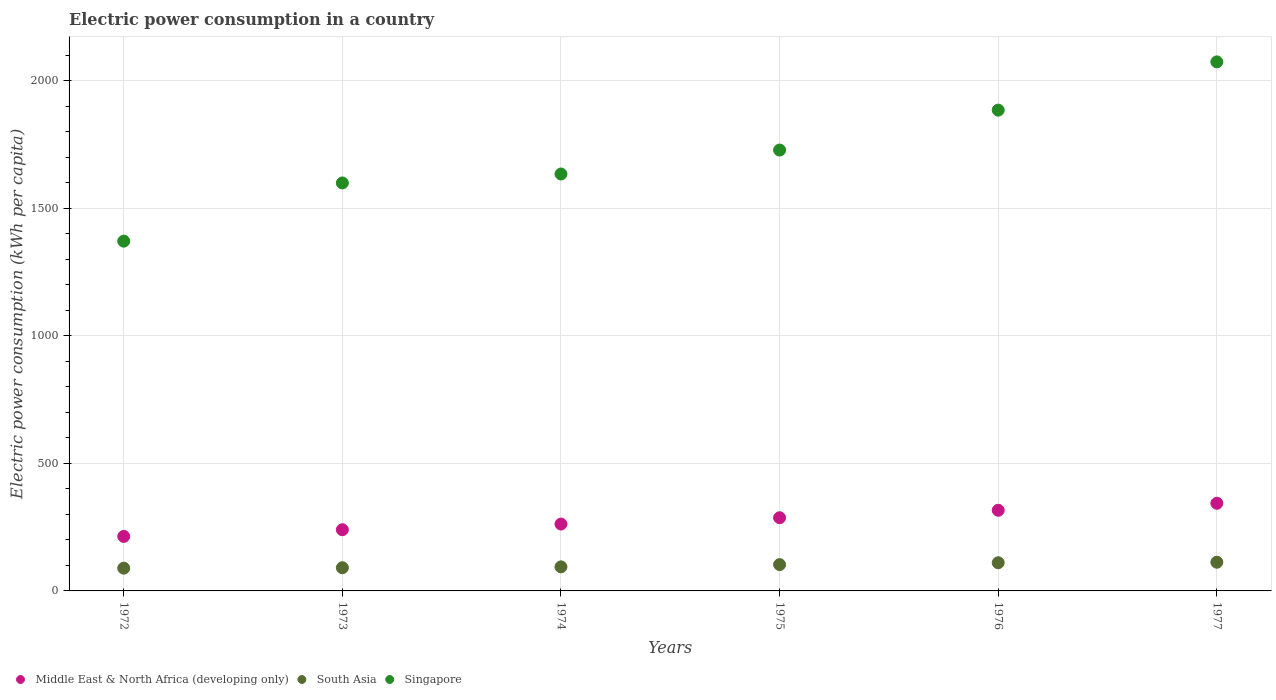Is the number of dotlines equal to the number of legend labels?
Make the answer very short. Yes. What is the electric power consumption in in South Asia in 1972?
Provide a succinct answer. 89.24. Across all years, what is the maximum electric power consumption in in South Asia?
Give a very brief answer. 112.5. Across all years, what is the minimum electric power consumption in in Middle East & North Africa (developing only)?
Your response must be concise. 213.69. In which year was the electric power consumption in in Singapore minimum?
Keep it short and to the point. 1972. What is the total electric power consumption in in Singapore in the graph?
Provide a short and direct response. 1.03e+04. What is the difference between the electric power consumption in in South Asia in 1973 and that in 1975?
Provide a short and direct response. -12.23. What is the difference between the electric power consumption in in Singapore in 1973 and the electric power consumption in in South Asia in 1976?
Ensure brevity in your answer.  1488.69. What is the average electric power consumption in in South Asia per year?
Provide a succinct answer. 100.08. In the year 1972, what is the difference between the electric power consumption in in South Asia and electric power consumption in in Singapore?
Keep it short and to the point. -1281.79. In how many years, is the electric power consumption in in Singapore greater than 1000 kWh per capita?
Offer a terse response. 6. What is the ratio of the electric power consumption in in Singapore in 1973 to that in 1976?
Offer a terse response. 0.85. Is the difference between the electric power consumption in in South Asia in 1973 and 1977 greater than the difference between the electric power consumption in in Singapore in 1973 and 1977?
Offer a terse response. Yes. What is the difference between the highest and the second highest electric power consumption in in South Asia?
Your answer should be compact. 2. What is the difference between the highest and the lowest electric power consumption in in Middle East & North Africa (developing only)?
Ensure brevity in your answer.  129.94. Is the electric power consumption in in South Asia strictly greater than the electric power consumption in in Middle East & North Africa (developing only) over the years?
Keep it short and to the point. No. How many years are there in the graph?
Provide a succinct answer. 6. Does the graph contain grids?
Your response must be concise. Yes. How are the legend labels stacked?
Ensure brevity in your answer.  Horizontal. What is the title of the graph?
Provide a succinct answer. Electric power consumption in a country. What is the label or title of the X-axis?
Offer a very short reply. Years. What is the label or title of the Y-axis?
Ensure brevity in your answer.  Electric power consumption (kWh per capita). What is the Electric power consumption (kWh per capita) in Middle East & North Africa (developing only) in 1972?
Provide a succinct answer. 213.69. What is the Electric power consumption (kWh per capita) of South Asia in 1972?
Give a very brief answer. 89.24. What is the Electric power consumption (kWh per capita) of Singapore in 1972?
Offer a very short reply. 1371.03. What is the Electric power consumption (kWh per capita) in Middle East & North Africa (developing only) in 1973?
Offer a terse response. 239.89. What is the Electric power consumption (kWh per capita) of South Asia in 1973?
Provide a short and direct response. 90.86. What is the Electric power consumption (kWh per capita) of Singapore in 1973?
Provide a short and direct response. 1599.18. What is the Electric power consumption (kWh per capita) in Middle East & North Africa (developing only) in 1974?
Your answer should be very brief. 262.09. What is the Electric power consumption (kWh per capita) of South Asia in 1974?
Your response must be concise. 94.28. What is the Electric power consumption (kWh per capita) in Singapore in 1974?
Offer a very short reply. 1634.23. What is the Electric power consumption (kWh per capita) of Middle East & North Africa (developing only) in 1975?
Offer a very short reply. 286.89. What is the Electric power consumption (kWh per capita) in South Asia in 1975?
Offer a terse response. 103.09. What is the Electric power consumption (kWh per capita) of Singapore in 1975?
Offer a very short reply. 1728.1. What is the Electric power consumption (kWh per capita) of Middle East & North Africa (developing only) in 1976?
Keep it short and to the point. 316.11. What is the Electric power consumption (kWh per capita) in South Asia in 1976?
Ensure brevity in your answer.  110.49. What is the Electric power consumption (kWh per capita) in Singapore in 1976?
Provide a short and direct response. 1884.62. What is the Electric power consumption (kWh per capita) of Middle East & North Africa (developing only) in 1977?
Keep it short and to the point. 343.64. What is the Electric power consumption (kWh per capita) in South Asia in 1977?
Ensure brevity in your answer.  112.5. What is the Electric power consumption (kWh per capita) of Singapore in 1977?
Your answer should be very brief. 2073.71. Across all years, what is the maximum Electric power consumption (kWh per capita) in Middle East & North Africa (developing only)?
Your response must be concise. 343.64. Across all years, what is the maximum Electric power consumption (kWh per capita) in South Asia?
Give a very brief answer. 112.5. Across all years, what is the maximum Electric power consumption (kWh per capita) in Singapore?
Ensure brevity in your answer.  2073.71. Across all years, what is the minimum Electric power consumption (kWh per capita) of Middle East & North Africa (developing only)?
Provide a succinct answer. 213.69. Across all years, what is the minimum Electric power consumption (kWh per capita) in South Asia?
Ensure brevity in your answer.  89.24. Across all years, what is the minimum Electric power consumption (kWh per capita) in Singapore?
Keep it short and to the point. 1371.03. What is the total Electric power consumption (kWh per capita) in Middle East & North Africa (developing only) in the graph?
Provide a short and direct response. 1662.3. What is the total Electric power consumption (kWh per capita) of South Asia in the graph?
Your answer should be compact. 600.47. What is the total Electric power consumption (kWh per capita) in Singapore in the graph?
Keep it short and to the point. 1.03e+04. What is the difference between the Electric power consumption (kWh per capita) in Middle East & North Africa (developing only) in 1972 and that in 1973?
Provide a succinct answer. -26.2. What is the difference between the Electric power consumption (kWh per capita) of South Asia in 1972 and that in 1973?
Your response must be concise. -1.62. What is the difference between the Electric power consumption (kWh per capita) in Singapore in 1972 and that in 1973?
Offer a terse response. -228.15. What is the difference between the Electric power consumption (kWh per capita) in Middle East & North Africa (developing only) in 1972 and that in 1974?
Keep it short and to the point. -48.4. What is the difference between the Electric power consumption (kWh per capita) in South Asia in 1972 and that in 1974?
Give a very brief answer. -5.04. What is the difference between the Electric power consumption (kWh per capita) in Singapore in 1972 and that in 1974?
Keep it short and to the point. -263.2. What is the difference between the Electric power consumption (kWh per capita) of Middle East & North Africa (developing only) in 1972 and that in 1975?
Offer a very short reply. -73.19. What is the difference between the Electric power consumption (kWh per capita) in South Asia in 1972 and that in 1975?
Provide a short and direct response. -13.85. What is the difference between the Electric power consumption (kWh per capita) of Singapore in 1972 and that in 1975?
Give a very brief answer. -357.07. What is the difference between the Electric power consumption (kWh per capita) of Middle East & North Africa (developing only) in 1972 and that in 1976?
Offer a very short reply. -102.41. What is the difference between the Electric power consumption (kWh per capita) of South Asia in 1972 and that in 1976?
Ensure brevity in your answer.  -21.25. What is the difference between the Electric power consumption (kWh per capita) of Singapore in 1972 and that in 1976?
Your response must be concise. -513.59. What is the difference between the Electric power consumption (kWh per capita) of Middle East & North Africa (developing only) in 1972 and that in 1977?
Ensure brevity in your answer.  -129.94. What is the difference between the Electric power consumption (kWh per capita) of South Asia in 1972 and that in 1977?
Ensure brevity in your answer.  -23.25. What is the difference between the Electric power consumption (kWh per capita) of Singapore in 1972 and that in 1977?
Your response must be concise. -702.68. What is the difference between the Electric power consumption (kWh per capita) in Middle East & North Africa (developing only) in 1973 and that in 1974?
Give a very brief answer. -22.2. What is the difference between the Electric power consumption (kWh per capita) in South Asia in 1973 and that in 1974?
Provide a succinct answer. -3.42. What is the difference between the Electric power consumption (kWh per capita) of Singapore in 1973 and that in 1974?
Provide a short and direct response. -35.05. What is the difference between the Electric power consumption (kWh per capita) of Middle East & North Africa (developing only) in 1973 and that in 1975?
Your response must be concise. -47. What is the difference between the Electric power consumption (kWh per capita) in South Asia in 1973 and that in 1975?
Your answer should be compact. -12.23. What is the difference between the Electric power consumption (kWh per capita) in Singapore in 1973 and that in 1975?
Your answer should be compact. -128.92. What is the difference between the Electric power consumption (kWh per capita) of Middle East & North Africa (developing only) in 1973 and that in 1976?
Make the answer very short. -76.22. What is the difference between the Electric power consumption (kWh per capita) of South Asia in 1973 and that in 1976?
Ensure brevity in your answer.  -19.63. What is the difference between the Electric power consumption (kWh per capita) of Singapore in 1973 and that in 1976?
Provide a short and direct response. -285.44. What is the difference between the Electric power consumption (kWh per capita) in Middle East & North Africa (developing only) in 1973 and that in 1977?
Your answer should be very brief. -103.75. What is the difference between the Electric power consumption (kWh per capita) of South Asia in 1973 and that in 1977?
Your answer should be compact. -21.63. What is the difference between the Electric power consumption (kWh per capita) of Singapore in 1973 and that in 1977?
Keep it short and to the point. -474.53. What is the difference between the Electric power consumption (kWh per capita) in Middle East & North Africa (developing only) in 1974 and that in 1975?
Your answer should be compact. -24.8. What is the difference between the Electric power consumption (kWh per capita) of South Asia in 1974 and that in 1975?
Ensure brevity in your answer.  -8.81. What is the difference between the Electric power consumption (kWh per capita) of Singapore in 1974 and that in 1975?
Provide a succinct answer. -93.87. What is the difference between the Electric power consumption (kWh per capita) in Middle East & North Africa (developing only) in 1974 and that in 1976?
Your answer should be very brief. -54.02. What is the difference between the Electric power consumption (kWh per capita) in South Asia in 1974 and that in 1976?
Offer a very short reply. -16.21. What is the difference between the Electric power consumption (kWh per capita) in Singapore in 1974 and that in 1976?
Your answer should be very brief. -250.39. What is the difference between the Electric power consumption (kWh per capita) of Middle East & North Africa (developing only) in 1974 and that in 1977?
Make the answer very short. -81.54. What is the difference between the Electric power consumption (kWh per capita) of South Asia in 1974 and that in 1977?
Your response must be concise. -18.21. What is the difference between the Electric power consumption (kWh per capita) in Singapore in 1974 and that in 1977?
Your answer should be compact. -439.48. What is the difference between the Electric power consumption (kWh per capita) of Middle East & North Africa (developing only) in 1975 and that in 1976?
Make the answer very short. -29.22. What is the difference between the Electric power consumption (kWh per capita) of South Asia in 1975 and that in 1976?
Provide a succinct answer. -7.4. What is the difference between the Electric power consumption (kWh per capita) in Singapore in 1975 and that in 1976?
Provide a short and direct response. -156.52. What is the difference between the Electric power consumption (kWh per capita) of Middle East & North Africa (developing only) in 1975 and that in 1977?
Provide a short and direct response. -56.75. What is the difference between the Electric power consumption (kWh per capita) in South Asia in 1975 and that in 1977?
Offer a very short reply. -9.4. What is the difference between the Electric power consumption (kWh per capita) of Singapore in 1975 and that in 1977?
Offer a very short reply. -345.61. What is the difference between the Electric power consumption (kWh per capita) in Middle East & North Africa (developing only) in 1976 and that in 1977?
Make the answer very short. -27.53. What is the difference between the Electric power consumption (kWh per capita) of South Asia in 1976 and that in 1977?
Give a very brief answer. -2. What is the difference between the Electric power consumption (kWh per capita) of Singapore in 1976 and that in 1977?
Your response must be concise. -189.09. What is the difference between the Electric power consumption (kWh per capita) in Middle East & North Africa (developing only) in 1972 and the Electric power consumption (kWh per capita) in South Asia in 1973?
Provide a succinct answer. 122.83. What is the difference between the Electric power consumption (kWh per capita) of Middle East & North Africa (developing only) in 1972 and the Electric power consumption (kWh per capita) of Singapore in 1973?
Make the answer very short. -1385.49. What is the difference between the Electric power consumption (kWh per capita) of South Asia in 1972 and the Electric power consumption (kWh per capita) of Singapore in 1973?
Make the answer very short. -1509.94. What is the difference between the Electric power consumption (kWh per capita) in Middle East & North Africa (developing only) in 1972 and the Electric power consumption (kWh per capita) in South Asia in 1974?
Provide a succinct answer. 119.41. What is the difference between the Electric power consumption (kWh per capita) of Middle East & North Africa (developing only) in 1972 and the Electric power consumption (kWh per capita) of Singapore in 1974?
Your answer should be compact. -1420.53. What is the difference between the Electric power consumption (kWh per capita) in South Asia in 1972 and the Electric power consumption (kWh per capita) in Singapore in 1974?
Give a very brief answer. -1544.98. What is the difference between the Electric power consumption (kWh per capita) in Middle East & North Africa (developing only) in 1972 and the Electric power consumption (kWh per capita) in South Asia in 1975?
Provide a succinct answer. 110.6. What is the difference between the Electric power consumption (kWh per capita) in Middle East & North Africa (developing only) in 1972 and the Electric power consumption (kWh per capita) in Singapore in 1975?
Ensure brevity in your answer.  -1514.41. What is the difference between the Electric power consumption (kWh per capita) in South Asia in 1972 and the Electric power consumption (kWh per capita) in Singapore in 1975?
Keep it short and to the point. -1638.86. What is the difference between the Electric power consumption (kWh per capita) in Middle East & North Africa (developing only) in 1972 and the Electric power consumption (kWh per capita) in South Asia in 1976?
Offer a terse response. 103.2. What is the difference between the Electric power consumption (kWh per capita) of Middle East & North Africa (developing only) in 1972 and the Electric power consumption (kWh per capita) of Singapore in 1976?
Your answer should be very brief. -1670.93. What is the difference between the Electric power consumption (kWh per capita) in South Asia in 1972 and the Electric power consumption (kWh per capita) in Singapore in 1976?
Your answer should be compact. -1795.38. What is the difference between the Electric power consumption (kWh per capita) of Middle East & North Africa (developing only) in 1972 and the Electric power consumption (kWh per capita) of South Asia in 1977?
Offer a terse response. 101.2. What is the difference between the Electric power consumption (kWh per capita) in Middle East & North Africa (developing only) in 1972 and the Electric power consumption (kWh per capita) in Singapore in 1977?
Provide a short and direct response. -1860.02. What is the difference between the Electric power consumption (kWh per capita) in South Asia in 1972 and the Electric power consumption (kWh per capita) in Singapore in 1977?
Provide a succinct answer. -1984.47. What is the difference between the Electric power consumption (kWh per capita) of Middle East & North Africa (developing only) in 1973 and the Electric power consumption (kWh per capita) of South Asia in 1974?
Offer a very short reply. 145.61. What is the difference between the Electric power consumption (kWh per capita) in Middle East & North Africa (developing only) in 1973 and the Electric power consumption (kWh per capita) in Singapore in 1974?
Give a very brief answer. -1394.34. What is the difference between the Electric power consumption (kWh per capita) in South Asia in 1973 and the Electric power consumption (kWh per capita) in Singapore in 1974?
Ensure brevity in your answer.  -1543.37. What is the difference between the Electric power consumption (kWh per capita) of Middle East & North Africa (developing only) in 1973 and the Electric power consumption (kWh per capita) of South Asia in 1975?
Make the answer very short. 136.8. What is the difference between the Electric power consumption (kWh per capita) of Middle East & North Africa (developing only) in 1973 and the Electric power consumption (kWh per capita) of Singapore in 1975?
Offer a terse response. -1488.21. What is the difference between the Electric power consumption (kWh per capita) in South Asia in 1973 and the Electric power consumption (kWh per capita) in Singapore in 1975?
Offer a terse response. -1637.24. What is the difference between the Electric power consumption (kWh per capita) in Middle East & North Africa (developing only) in 1973 and the Electric power consumption (kWh per capita) in South Asia in 1976?
Your answer should be compact. 129.4. What is the difference between the Electric power consumption (kWh per capita) of Middle East & North Africa (developing only) in 1973 and the Electric power consumption (kWh per capita) of Singapore in 1976?
Offer a very short reply. -1644.73. What is the difference between the Electric power consumption (kWh per capita) of South Asia in 1973 and the Electric power consumption (kWh per capita) of Singapore in 1976?
Make the answer very short. -1793.76. What is the difference between the Electric power consumption (kWh per capita) in Middle East & North Africa (developing only) in 1973 and the Electric power consumption (kWh per capita) in South Asia in 1977?
Ensure brevity in your answer.  127.39. What is the difference between the Electric power consumption (kWh per capita) of Middle East & North Africa (developing only) in 1973 and the Electric power consumption (kWh per capita) of Singapore in 1977?
Keep it short and to the point. -1833.82. What is the difference between the Electric power consumption (kWh per capita) of South Asia in 1973 and the Electric power consumption (kWh per capita) of Singapore in 1977?
Provide a short and direct response. -1982.85. What is the difference between the Electric power consumption (kWh per capita) of Middle East & North Africa (developing only) in 1974 and the Electric power consumption (kWh per capita) of South Asia in 1975?
Make the answer very short. 159. What is the difference between the Electric power consumption (kWh per capita) in Middle East & North Africa (developing only) in 1974 and the Electric power consumption (kWh per capita) in Singapore in 1975?
Provide a short and direct response. -1466.01. What is the difference between the Electric power consumption (kWh per capita) in South Asia in 1974 and the Electric power consumption (kWh per capita) in Singapore in 1975?
Offer a very short reply. -1633.82. What is the difference between the Electric power consumption (kWh per capita) in Middle East & North Africa (developing only) in 1974 and the Electric power consumption (kWh per capita) in South Asia in 1976?
Your answer should be very brief. 151.6. What is the difference between the Electric power consumption (kWh per capita) in Middle East & North Africa (developing only) in 1974 and the Electric power consumption (kWh per capita) in Singapore in 1976?
Keep it short and to the point. -1622.53. What is the difference between the Electric power consumption (kWh per capita) in South Asia in 1974 and the Electric power consumption (kWh per capita) in Singapore in 1976?
Offer a very short reply. -1790.34. What is the difference between the Electric power consumption (kWh per capita) in Middle East & North Africa (developing only) in 1974 and the Electric power consumption (kWh per capita) in South Asia in 1977?
Offer a terse response. 149.6. What is the difference between the Electric power consumption (kWh per capita) of Middle East & North Africa (developing only) in 1974 and the Electric power consumption (kWh per capita) of Singapore in 1977?
Keep it short and to the point. -1811.62. What is the difference between the Electric power consumption (kWh per capita) in South Asia in 1974 and the Electric power consumption (kWh per capita) in Singapore in 1977?
Keep it short and to the point. -1979.43. What is the difference between the Electric power consumption (kWh per capita) in Middle East & North Africa (developing only) in 1975 and the Electric power consumption (kWh per capita) in South Asia in 1976?
Give a very brief answer. 176.4. What is the difference between the Electric power consumption (kWh per capita) of Middle East & North Africa (developing only) in 1975 and the Electric power consumption (kWh per capita) of Singapore in 1976?
Ensure brevity in your answer.  -1597.73. What is the difference between the Electric power consumption (kWh per capita) of South Asia in 1975 and the Electric power consumption (kWh per capita) of Singapore in 1976?
Your answer should be compact. -1781.53. What is the difference between the Electric power consumption (kWh per capita) in Middle East & North Africa (developing only) in 1975 and the Electric power consumption (kWh per capita) in South Asia in 1977?
Offer a very short reply. 174.39. What is the difference between the Electric power consumption (kWh per capita) of Middle East & North Africa (developing only) in 1975 and the Electric power consumption (kWh per capita) of Singapore in 1977?
Give a very brief answer. -1786.82. What is the difference between the Electric power consumption (kWh per capita) in South Asia in 1975 and the Electric power consumption (kWh per capita) in Singapore in 1977?
Make the answer very short. -1970.62. What is the difference between the Electric power consumption (kWh per capita) in Middle East & North Africa (developing only) in 1976 and the Electric power consumption (kWh per capita) in South Asia in 1977?
Offer a very short reply. 203.61. What is the difference between the Electric power consumption (kWh per capita) in Middle East & North Africa (developing only) in 1976 and the Electric power consumption (kWh per capita) in Singapore in 1977?
Your response must be concise. -1757.6. What is the difference between the Electric power consumption (kWh per capita) of South Asia in 1976 and the Electric power consumption (kWh per capita) of Singapore in 1977?
Provide a succinct answer. -1963.22. What is the average Electric power consumption (kWh per capita) in Middle East & North Africa (developing only) per year?
Make the answer very short. 277.05. What is the average Electric power consumption (kWh per capita) in South Asia per year?
Your answer should be compact. 100.08. What is the average Electric power consumption (kWh per capita) in Singapore per year?
Provide a succinct answer. 1715.14. In the year 1972, what is the difference between the Electric power consumption (kWh per capita) of Middle East & North Africa (developing only) and Electric power consumption (kWh per capita) of South Asia?
Make the answer very short. 124.45. In the year 1972, what is the difference between the Electric power consumption (kWh per capita) of Middle East & North Africa (developing only) and Electric power consumption (kWh per capita) of Singapore?
Ensure brevity in your answer.  -1157.33. In the year 1972, what is the difference between the Electric power consumption (kWh per capita) of South Asia and Electric power consumption (kWh per capita) of Singapore?
Your response must be concise. -1281.79. In the year 1973, what is the difference between the Electric power consumption (kWh per capita) of Middle East & North Africa (developing only) and Electric power consumption (kWh per capita) of South Asia?
Provide a succinct answer. 149.03. In the year 1973, what is the difference between the Electric power consumption (kWh per capita) in Middle East & North Africa (developing only) and Electric power consumption (kWh per capita) in Singapore?
Your answer should be very brief. -1359.29. In the year 1973, what is the difference between the Electric power consumption (kWh per capita) of South Asia and Electric power consumption (kWh per capita) of Singapore?
Give a very brief answer. -1508.32. In the year 1974, what is the difference between the Electric power consumption (kWh per capita) in Middle East & North Africa (developing only) and Electric power consumption (kWh per capita) in South Asia?
Provide a short and direct response. 167.81. In the year 1974, what is the difference between the Electric power consumption (kWh per capita) of Middle East & North Africa (developing only) and Electric power consumption (kWh per capita) of Singapore?
Provide a succinct answer. -1372.14. In the year 1974, what is the difference between the Electric power consumption (kWh per capita) of South Asia and Electric power consumption (kWh per capita) of Singapore?
Offer a terse response. -1539.95. In the year 1975, what is the difference between the Electric power consumption (kWh per capita) in Middle East & North Africa (developing only) and Electric power consumption (kWh per capita) in South Asia?
Give a very brief answer. 183.79. In the year 1975, what is the difference between the Electric power consumption (kWh per capita) in Middle East & North Africa (developing only) and Electric power consumption (kWh per capita) in Singapore?
Provide a short and direct response. -1441.21. In the year 1975, what is the difference between the Electric power consumption (kWh per capita) in South Asia and Electric power consumption (kWh per capita) in Singapore?
Give a very brief answer. -1625.01. In the year 1976, what is the difference between the Electric power consumption (kWh per capita) of Middle East & North Africa (developing only) and Electric power consumption (kWh per capita) of South Asia?
Offer a very short reply. 205.62. In the year 1976, what is the difference between the Electric power consumption (kWh per capita) of Middle East & North Africa (developing only) and Electric power consumption (kWh per capita) of Singapore?
Provide a succinct answer. -1568.51. In the year 1976, what is the difference between the Electric power consumption (kWh per capita) in South Asia and Electric power consumption (kWh per capita) in Singapore?
Ensure brevity in your answer.  -1774.13. In the year 1977, what is the difference between the Electric power consumption (kWh per capita) of Middle East & North Africa (developing only) and Electric power consumption (kWh per capita) of South Asia?
Offer a terse response. 231.14. In the year 1977, what is the difference between the Electric power consumption (kWh per capita) of Middle East & North Africa (developing only) and Electric power consumption (kWh per capita) of Singapore?
Make the answer very short. -1730.08. In the year 1977, what is the difference between the Electric power consumption (kWh per capita) of South Asia and Electric power consumption (kWh per capita) of Singapore?
Provide a short and direct response. -1961.22. What is the ratio of the Electric power consumption (kWh per capita) of Middle East & North Africa (developing only) in 1972 to that in 1973?
Offer a terse response. 0.89. What is the ratio of the Electric power consumption (kWh per capita) of South Asia in 1972 to that in 1973?
Ensure brevity in your answer.  0.98. What is the ratio of the Electric power consumption (kWh per capita) in Singapore in 1972 to that in 1973?
Keep it short and to the point. 0.86. What is the ratio of the Electric power consumption (kWh per capita) in Middle East & North Africa (developing only) in 1972 to that in 1974?
Offer a very short reply. 0.82. What is the ratio of the Electric power consumption (kWh per capita) of South Asia in 1972 to that in 1974?
Keep it short and to the point. 0.95. What is the ratio of the Electric power consumption (kWh per capita) of Singapore in 1972 to that in 1974?
Provide a short and direct response. 0.84. What is the ratio of the Electric power consumption (kWh per capita) in Middle East & North Africa (developing only) in 1972 to that in 1975?
Keep it short and to the point. 0.74. What is the ratio of the Electric power consumption (kWh per capita) in South Asia in 1972 to that in 1975?
Offer a terse response. 0.87. What is the ratio of the Electric power consumption (kWh per capita) of Singapore in 1972 to that in 1975?
Keep it short and to the point. 0.79. What is the ratio of the Electric power consumption (kWh per capita) of Middle East & North Africa (developing only) in 1972 to that in 1976?
Your answer should be compact. 0.68. What is the ratio of the Electric power consumption (kWh per capita) in South Asia in 1972 to that in 1976?
Your response must be concise. 0.81. What is the ratio of the Electric power consumption (kWh per capita) in Singapore in 1972 to that in 1976?
Offer a very short reply. 0.73. What is the ratio of the Electric power consumption (kWh per capita) in Middle East & North Africa (developing only) in 1972 to that in 1977?
Make the answer very short. 0.62. What is the ratio of the Electric power consumption (kWh per capita) in South Asia in 1972 to that in 1977?
Provide a short and direct response. 0.79. What is the ratio of the Electric power consumption (kWh per capita) of Singapore in 1972 to that in 1977?
Provide a short and direct response. 0.66. What is the ratio of the Electric power consumption (kWh per capita) of Middle East & North Africa (developing only) in 1973 to that in 1974?
Offer a terse response. 0.92. What is the ratio of the Electric power consumption (kWh per capita) of South Asia in 1973 to that in 1974?
Provide a short and direct response. 0.96. What is the ratio of the Electric power consumption (kWh per capita) in Singapore in 1973 to that in 1974?
Your answer should be very brief. 0.98. What is the ratio of the Electric power consumption (kWh per capita) in Middle East & North Africa (developing only) in 1973 to that in 1975?
Your answer should be very brief. 0.84. What is the ratio of the Electric power consumption (kWh per capita) of South Asia in 1973 to that in 1975?
Your answer should be very brief. 0.88. What is the ratio of the Electric power consumption (kWh per capita) in Singapore in 1973 to that in 1975?
Your answer should be compact. 0.93. What is the ratio of the Electric power consumption (kWh per capita) in Middle East & North Africa (developing only) in 1973 to that in 1976?
Offer a very short reply. 0.76. What is the ratio of the Electric power consumption (kWh per capita) of South Asia in 1973 to that in 1976?
Offer a very short reply. 0.82. What is the ratio of the Electric power consumption (kWh per capita) in Singapore in 1973 to that in 1976?
Your response must be concise. 0.85. What is the ratio of the Electric power consumption (kWh per capita) in Middle East & North Africa (developing only) in 1973 to that in 1977?
Provide a short and direct response. 0.7. What is the ratio of the Electric power consumption (kWh per capita) in South Asia in 1973 to that in 1977?
Make the answer very short. 0.81. What is the ratio of the Electric power consumption (kWh per capita) of Singapore in 1973 to that in 1977?
Your response must be concise. 0.77. What is the ratio of the Electric power consumption (kWh per capita) in Middle East & North Africa (developing only) in 1974 to that in 1975?
Provide a succinct answer. 0.91. What is the ratio of the Electric power consumption (kWh per capita) in South Asia in 1974 to that in 1975?
Offer a terse response. 0.91. What is the ratio of the Electric power consumption (kWh per capita) in Singapore in 1974 to that in 1975?
Offer a very short reply. 0.95. What is the ratio of the Electric power consumption (kWh per capita) of Middle East & North Africa (developing only) in 1974 to that in 1976?
Your response must be concise. 0.83. What is the ratio of the Electric power consumption (kWh per capita) of South Asia in 1974 to that in 1976?
Ensure brevity in your answer.  0.85. What is the ratio of the Electric power consumption (kWh per capita) in Singapore in 1974 to that in 1976?
Provide a short and direct response. 0.87. What is the ratio of the Electric power consumption (kWh per capita) of Middle East & North Africa (developing only) in 1974 to that in 1977?
Give a very brief answer. 0.76. What is the ratio of the Electric power consumption (kWh per capita) in South Asia in 1974 to that in 1977?
Give a very brief answer. 0.84. What is the ratio of the Electric power consumption (kWh per capita) in Singapore in 1974 to that in 1977?
Ensure brevity in your answer.  0.79. What is the ratio of the Electric power consumption (kWh per capita) of Middle East & North Africa (developing only) in 1975 to that in 1976?
Provide a succinct answer. 0.91. What is the ratio of the Electric power consumption (kWh per capita) of South Asia in 1975 to that in 1976?
Provide a succinct answer. 0.93. What is the ratio of the Electric power consumption (kWh per capita) of Singapore in 1975 to that in 1976?
Your answer should be compact. 0.92. What is the ratio of the Electric power consumption (kWh per capita) in Middle East & North Africa (developing only) in 1975 to that in 1977?
Your response must be concise. 0.83. What is the ratio of the Electric power consumption (kWh per capita) in South Asia in 1975 to that in 1977?
Your answer should be very brief. 0.92. What is the ratio of the Electric power consumption (kWh per capita) of Middle East & North Africa (developing only) in 1976 to that in 1977?
Provide a succinct answer. 0.92. What is the ratio of the Electric power consumption (kWh per capita) in South Asia in 1976 to that in 1977?
Provide a short and direct response. 0.98. What is the ratio of the Electric power consumption (kWh per capita) of Singapore in 1976 to that in 1977?
Make the answer very short. 0.91. What is the difference between the highest and the second highest Electric power consumption (kWh per capita) of Middle East & North Africa (developing only)?
Make the answer very short. 27.53. What is the difference between the highest and the second highest Electric power consumption (kWh per capita) of South Asia?
Your answer should be very brief. 2. What is the difference between the highest and the second highest Electric power consumption (kWh per capita) in Singapore?
Your response must be concise. 189.09. What is the difference between the highest and the lowest Electric power consumption (kWh per capita) of Middle East & North Africa (developing only)?
Offer a terse response. 129.94. What is the difference between the highest and the lowest Electric power consumption (kWh per capita) in South Asia?
Offer a terse response. 23.25. What is the difference between the highest and the lowest Electric power consumption (kWh per capita) in Singapore?
Ensure brevity in your answer.  702.68. 